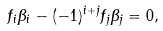<formula> <loc_0><loc_0><loc_500><loc_500>f _ { i } \beta _ { i } - ( - 1 ) ^ { i + j } f _ { j } \beta _ { j } = 0 ,</formula> 